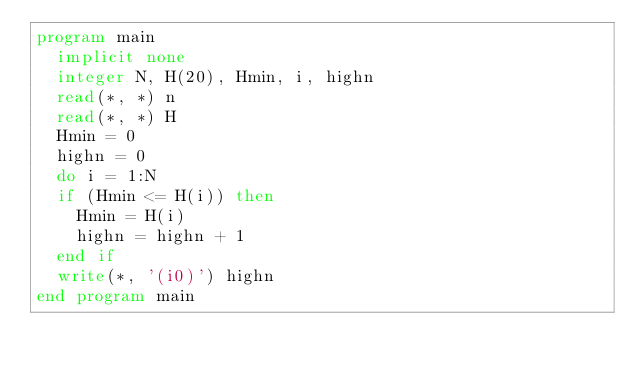<code> <loc_0><loc_0><loc_500><loc_500><_FORTRAN_>program main
  implicit none
  integer N, H(20), Hmin, i, highn
  read(*, *) n
  read(*, *) H
  Hmin = 0
  highn = 0
  do i = 1:N
  if (Hmin <= H(i)) then
    Hmin = H(i)
    highn = highn + 1
  end if
  write(*, '(i0)') highn
end program main</code> 